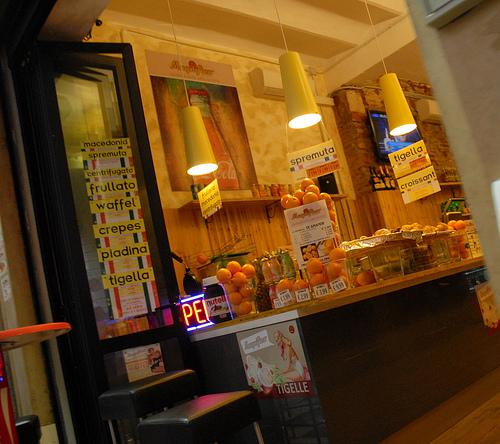Question: how many lights are on?
Choices:
A. Four.
B. Five.
C. Three.
D. Six.
Answer with the letter. Answer: C Question: what color are the floors?
Choices:
A. Gray.
B. Hardwood brown.
C. White.
D. Black.
Answer with the letter. Answer: B Question: what is in the picture?
Choices:
A. Trees.
B. People.
C. Cars.
D. Oranges and signs.
Answer with the letter. Answer: D Question: how many people are in the picture?
Choices:
A. None.
B. One.
C. Two.
D. Three.
Answer with the letter. Answer: A 